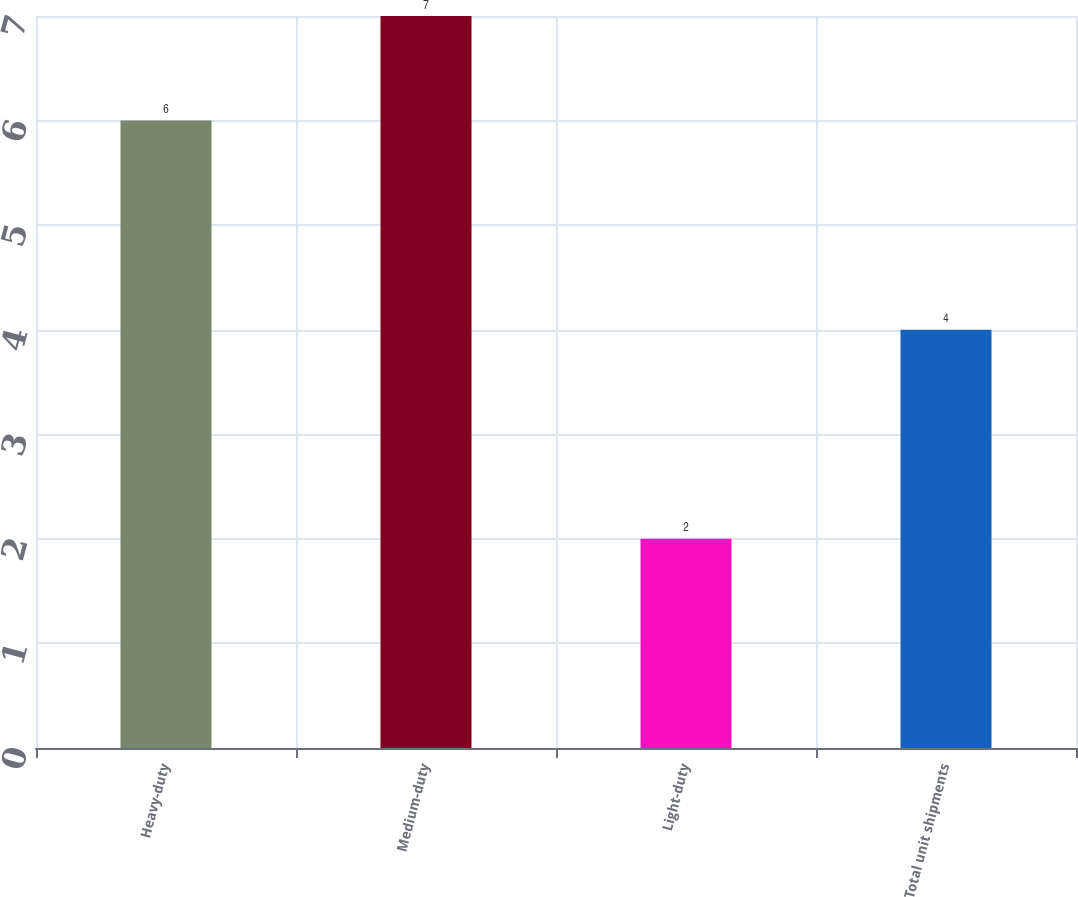<chart> <loc_0><loc_0><loc_500><loc_500><bar_chart><fcel>Heavy-duty<fcel>Medium-duty<fcel>Light-duty<fcel>Total unit shipments<nl><fcel>6<fcel>7<fcel>2<fcel>4<nl></chart> 